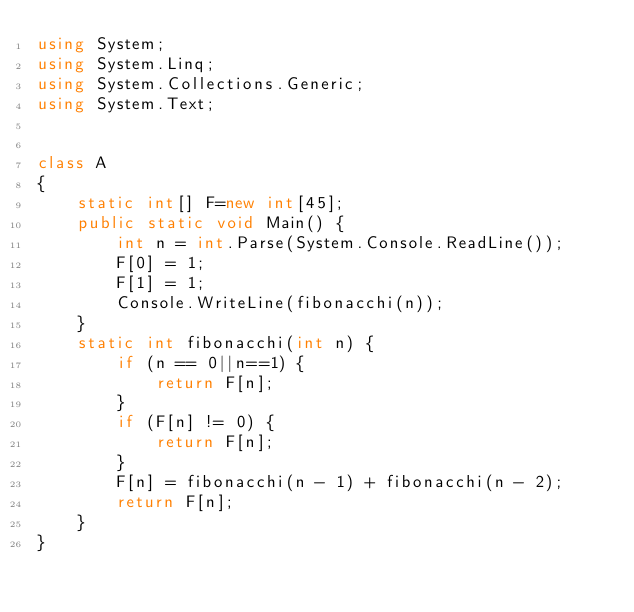<code> <loc_0><loc_0><loc_500><loc_500><_C#_>using System;
using System.Linq;
using System.Collections.Generic;
using System.Text;


class A
{
    static int[] F=new int[45];
    public static void Main() {
        int n = int.Parse(System.Console.ReadLine());
        F[0] = 1;
        F[1] = 1;
        Console.WriteLine(fibonacchi(n));
    }
    static int fibonacchi(int n) {
        if (n == 0||n==1) {
            return F[n];
        }
        if (F[n] != 0) {
            return F[n];
        }
        F[n] = fibonacchi(n - 1) + fibonacchi(n - 2);
        return F[n];
    }
}
</code> 